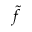Convert formula to latex. <formula><loc_0><loc_0><loc_500><loc_500>\widetilde { f }</formula> 